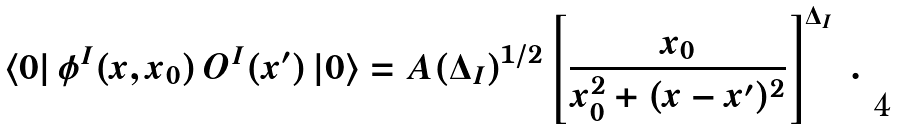Convert formula to latex. <formula><loc_0><loc_0><loc_500><loc_500>\langle 0 | \, \phi ^ { I } ( x , x _ { 0 } ) \, O ^ { I } ( x ^ { \prime } ) \, | 0 \rangle = { A ( \Delta _ { I } ) } ^ { 1 / 2 } \left [ \frac { x _ { 0 } } { x _ { 0 } ^ { 2 } + ( x - x ^ { \prime } ) ^ { 2 } } \right ] ^ { \Delta _ { I } } \ .</formula> 